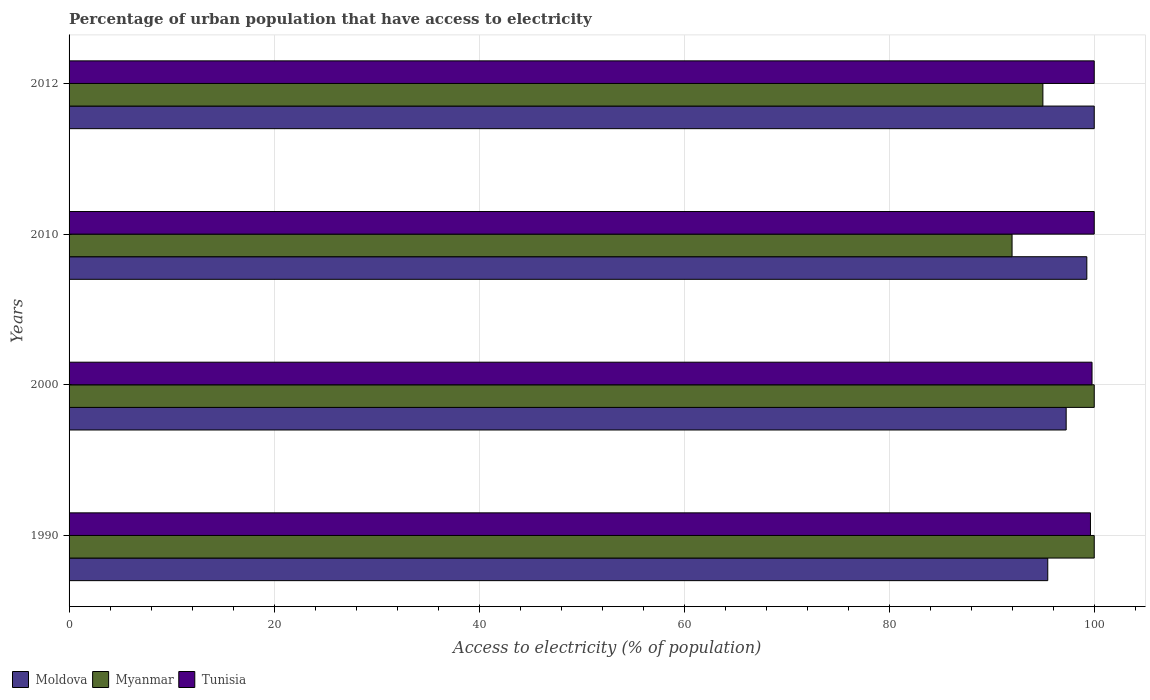How many groups of bars are there?
Provide a succinct answer. 4. How many bars are there on the 2nd tick from the bottom?
Give a very brief answer. 3. In how many cases, is the number of bars for a given year not equal to the number of legend labels?
Provide a short and direct response. 0. What is the percentage of urban population that have access to electricity in Moldova in 1990?
Your response must be concise. 95.47. Across all years, what is the minimum percentage of urban population that have access to electricity in Myanmar?
Provide a short and direct response. 91.99. In which year was the percentage of urban population that have access to electricity in Myanmar maximum?
Provide a short and direct response. 1990. What is the total percentage of urban population that have access to electricity in Tunisia in the graph?
Provide a succinct answer. 399.42. What is the difference between the percentage of urban population that have access to electricity in Moldova in 1990 and that in 2012?
Make the answer very short. -4.53. What is the difference between the percentage of urban population that have access to electricity in Tunisia in 2000 and the percentage of urban population that have access to electricity in Moldova in 2012?
Make the answer very short. -0.22. What is the average percentage of urban population that have access to electricity in Myanmar per year?
Your response must be concise. 96.74. In the year 2000, what is the difference between the percentage of urban population that have access to electricity in Tunisia and percentage of urban population that have access to electricity in Moldova?
Make the answer very short. 2.52. In how many years, is the percentage of urban population that have access to electricity in Myanmar greater than 84 %?
Offer a terse response. 4. What is the ratio of the percentage of urban population that have access to electricity in Myanmar in 2010 to that in 2012?
Your answer should be very brief. 0.97. Is the percentage of urban population that have access to electricity in Moldova in 1990 less than that in 2000?
Ensure brevity in your answer.  Yes. What is the difference between the highest and the lowest percentage of urban population that have access to electricity in Moldova?
Ensure brevity in your answer.  4.53. Is the sum of the percentage of urban population that have access to electricity in Tunisia in 1990 and 2012 greater than the maximum percentage of urban population that have access to electricity in Myanmar across all years?
Keep it short and to the point. Yes. What does the 2nd bar from the top in 1990 represents?
Provide a succinct answer. Myanmar. What does the 1st bar from the bottom in 2000 represents?
Offer a terse response. Moldova. Is it the case that in every year, the sum of the percentage of urban population that have access to electricity in Tunisia and percentage of urban population that have access to electricity in Moldova is greater than the percentage of urban population that have access to electricity in Myanmar?
Provide a short and direct response. Yes. Are all the bars in the graph horizontal?
Keep it short and to the point. Yes. Does the graph contain any zero values?
Offer a very short reply. No. Does the graph contain grids?
Give a very brief answer. Yes. Where does the legend appear in the graph?
Provide a succinct answer. Bottom left. How many legend labels are there?
Your answer should be very brief. 3. How are the legend labels stacked?
Ensure brevity in your answer.  Horizontal. What is the title of the graph?
Your answer should be very brief. Percentage of urban population that have access to electricity. Does "Central Europe" appear as one of the legend labels in the graph?
Provide a short and direct response. No. What is the label or title of the X-axis?
Your answer should be compact. Access to electricity (% of population). What is the label or title of the Y-axis?
Provide a succinct answer. Years. What is the Access to electricity (% of population) of Moldova in 1990?
Make the answer very short. 95.47. What is the Access to electricity (% of population) of Myanmar in 1990?
Your response must be concise. 100. What is the Access to electricity (% of population) of Tunisia in 1990?
Your response must be concise. 99.63. What is the Access to electricity (% of population) in Moldova in 2000?
Make the answer very short. 97.26. What is the Access to electricity (% of population) in Myanmar in 2000?
Make the answer very short. 100. What is the Access to electricity (% of population) of Tunisia in 2000?
Your response must be concise. 99.78. What is the Access to electricity (% of population) in Moldova in 2010?
Provide a short and direct response. 99.28. What is the Access to electricity (% of population) in Myanmar in 2010?
Your answer should be compact. 91.99. What is the Access to electricity (% of population) in Tunisia in 2010?
Ensure brevity in your answer.  100. What is the Access to electricity (% of population) in Myanmar in 2012?
Make the answer very short. 94.99. What is the Access to electricity (% of population) in Tunisia in 2012?
Provide a succinct answer. 100. Across all years, what is the maximum Access to electricity (% of population) in Tunisia?
Keep it short and to the point. 100. Across all years, what is the minimum Access to electricity (% of population) in Moldova?
Keep it short and to the point. 95.47. Across all years, what is the minimum Access to electricity (% of population) in Myanmar?
Give a very brief answer. 91.99. Across all years, what is the minimum Access to electricity (% of population) in Tunisia?
Ensure brevity in your answer.  99.63. What is the total Access to electricity (% of population) of Moldova in the graph?
Your answer should be compact. 392.01. What is the total Access to electricity (% of population) of Myanmar in the graph?
Make the answer very short. 386.98. What is the total Access to electricity (% of population) of Tunisia in the graph?
Your answer should be very brief. 399.42. What is the difference between the Access to electricity (% of population) of Moldova in 1990 and that in 2000?
Ensure brevity in your answer.  -1.8. What is the difference between the Access to electricity (% of population) of Myanmar in 1990 and that in 2000?
Ensure brevity in your answer.  0. What is the difference between the Access to electricity (% of population) of Tunisia in 1990 and that in 2000?
Offer a terse response. -0.15. What is the difference between the Access to electricity (% of population) in Moldova in 1990 and that in 2010?
Your response must be concise. -3.81. What is the difference between the Access to electricity (% of population) of Myanmar in 1990 and that in 2010?
Provide a succinct answer. 8.01. What is the difference between the Access to electricity (% of population) in Tunisia in 1990 and that in 2010?
Your answer should be compact. -0.37. What is the difference between the Access to electricity (% of population) of Moldova in 1990 and that in 2012?
Your response must be concise. -4.53. What is the difference between the Access to electricity (% of population) of Myanmar in 1990 and that in 2012?
Offer a terse response. 5.01. What is the difference between the Access to electricity (% of population) of Tunisia in 1990 and that in 2012?
Offer a very short reply. -0.37. What is the difference between the Access to electricity (% of population) in Moldova in 2000 and that in 2010?
Your answer should be very brief. -2.02. What is the difference between the Access to electricity (% of population) of Myanmar in 2000 and that in 2010?
Give a very brief answer. 8.01. What is the difference between the Access to electricity (% of population) in Tunisia in 2000 and that in 2010?
Give a very brief answer. -0.22. What is the difference between the Access to electricity (% of population) in Moldova in 2000 and that in 2012?
Offer a terse response. -2.74. What is the difference between the Access to electricity (% of population) in Myanmar in 2000 and that in 2012?
Your answer should be very brief. 5.01. What is the difference between the Access to electricity (% of population) in Tunisia in 2000 and that in 2012?
Your answer should be very brief. -0.22. What is the difference between the Access to electricity (% of population) of Moldova in 2010 and that in 2012?
Make the answer very short. -0.72. What is the difference between the Access to electricity (% of population) in Myanmar in 2010 and that in 2012?
Keep it short and to the point. -3.01. What is the difference between the Access to electricity (% of population) of Moldova in 1990 and the Access to electricity (% of population) of Myanmar in 2000?
Offer a terse response. -4.53. What is the difference between the Access to electricity (% of population) of Moldova in 1990 and the Access to electricity (% of population) of Tunisia in 2000?
Offer a very short reply. -4.32. What is the difference between the Access to electricity (% of population) in Myanmar in 1990 and the Access to electricity (% of population) in Tunisia in 2000?
Provide a short and direct response. 0.22. What is the difference between the Access to electricity (% of population) in Moldova in 1990 and the Access to electricity (% of population) in Myanmar in 2010?
Your response must be concise. 3.48. What is the difference between the Access to electricity (% of population) of Moldova in 1990 and the Access to electricity (% of population) of Tunisia in 2010?
Your answer should be very brief. -4.53. What is the difference between the Access to electricity (% of population) of Moldova in 1990 and the Access to electricity (% of population) of Myanmar in 2012?
Your response must be concise. 0.47. What is the difference between the Access to electricity (% of population) of Moldova in 1990 and the Access to electricity (% of population) of Tunisia in 2012?
Provide a short and direct response. -4.53. What is the difference between the Access to electricity (% of population) in Moldova in 2000 and the Access to electricity (% of population) in Myanmar in 2010?
Your answer should be very brief. 5.28. What is the difference between the Access to electricity (% of population) in Moldova in 2000 and the Access to electricity (% of population) in Tunisia in 2010?
Offer a terse response. -2.74. What is the difference between the Access to electricity (% of population) in Moldova in 2000 and the Access to electricity (% of population) in Myanmar in 2012?
Ensure brevity in your answer.  2.27. What is the difference between the Access to electricity (% of population) of Moldova in 2000 and the Access to electricity (% of population) of Tunisia in 2012?
Provide a succinct answer. -2.74. What is the difference between the Access to electricity (% of population) in Moldova in 2010 and the Access to electricity (% of population) in Myanmar in 2012?
Ensure brevity in your answer.  4.29. What is the difference between the Access to electricity (% of population) in Moldova in 2010 and the Access to electricity (% of population) in Tunisia in 2012?
Offer a very short reply. -0.72. What is the difference between the Access to electricity (% of population) of Myanmar in 2010 and the Access to electricity (% of population) of Tunisia in 2012?
Make the answer very short. -8.01. What is the average Access to electricity (% of population) of Moldova per year?
Ensure brevity in your answer.  98. What is the average Access to electricity (% of population) of Myanmar per year?
Provide a succinct answer. 96.74. What is the average Access to electricity (% of population) in Tunisia per year?
Your response must be concise. 99.85. In the year 1990, what is the difference between the Access to electricity (% of population) in Moldova and Access to electricity (% of population) in Myanmar?
Your answer should be very brief. -4.53. In the year 1990, what is the difference between the Access to electricity (% of population) in Moldova and Access to electricity (% of population) in Tunisia?
Ensure brevity in your answer.  -4.17. In the year 1990, what is the difference between the Access to electricity (% of population) of Myanmar and Access to electricity (% of population) of Tunisia?
Give a very brief answer. 0.37. In the year 2000, what is the difference between the Access to electricity (% of population) of Moldova and Access to electricity (% of population) of Myanmar?
Provide a short and direct response. -2.74. In the year 2000, what is the difference between the Access to electricity (% of population) of Moldova and Access to electricity (% of population) of Tunisia?
Your response must be concise. -2.52. In the year 2000, what is the difference between the Access to electricity (% of population) in Myanmar and Access to electricity (% of population) in Tunisia?
Make the answer very short. 0.22. In the year 2010, what is the difference between the Access to electricity (% of population) in Moldova and Access to electricity (% of population) in Myanmar?
Your answer should be very brief. 7.29. In the year 2010, what is the difference between the Access to electricity (% of population) in Moldova and Access to electricity (% of population) in Tunisia?
Provide a succinct answer. -0.72. In the year 2010, what is the difference between the Access to electricity (% of population) in Myanmar and Access to electricity (% of population) in Tunisia?
Provide a short and direct response. -8.01. In the year 2012, what is the difference between the Access to electricity (% of population) in Moldova and Access to electricity (% of population) in Myanmar?
Ensure brevity in your answer.  5.01. In the year 2012, what is the difference between the Access to electricity (% of population) of Moldova and Access to electricity (% of population) of Tunisia?
Provide a short and direct response. 0. In the year 2012, what is the difference between the Access to electricity (% of population) in Myanmar and Access to electricity (% of population) in Tunisia?
Ensure brevity in your answer.  -5.01. What is the ratio of the Access to electricity (% of population) of Moldova in 1990 to that in 2000?
Make the answer very short. 0.98. What is the ratio of the Access to electricity (% of population) of Myanmar in 1990 to that in 2000?
Provide a succinct answer. 1. What is the ratio of the Access to electricity (% of population) of Moldova in 1990 to that in 2010?
Make the answer very short. 0.96. What is the ratio of the Access to electricity (% of population) in Myanmar in 1990 to that in 2010?
Keep it short and to the point. 1.09. What is the ratio of the Access to electricity (% of population) in Moldova in 1990 to that in 2012?
Your response must be concise. 0.95. What is the ratio of the Access to electricity (% of population) of Myanmar in 1990 to that in 2012?
Keep it short and to the point. 1.05. What is the ratio of the Access to electricity (% of population) of Moldova in 2000 to that in 2010?
Your response must be concise. 0.98. What is the ratio of the Access to electricity (% of population) in Myanmar in 2000 to that in 2010?
Your response must be concise. 1.09. What is the ratio of the Access to electricity (% of population) of Moldova in 2000 to that in 2012?
Provide a succinct answer. 0.97. What is the ratio of the Access to electricity (% of population) in Myanmar in 2000 to that in 2012?
Provide a succinct answer. 1.05. What is the ratio of the Access to electricity (% of population) of Tunisia in 2000 to that in 2012?
Your answer should be very brief. 1. What is the ratio of the Access to electricity (% of population) in Moldova in 2010 to that in 2012?
Your answer should be very brief. 0.99. What is the ratio of the Access to electricity (% of population) of Myanmar in 2010 to that in 2012?
Your response must be concise. 0.97. What is the difference between the highest and the second highest Access to electricity (% of population) in Moldova?
Your answer should be compact. 0.72. What is the difference between the highest and the second highest Access to electricity (% of population) in Myanmar?
Keep it short and to the point. 0. What is the difference between the highest and the lowest Access to electricity (% of population) of Moldova?
Your answer should be compact. 4.53. What is the difference between the highest and the lowest Access to electricity (% of population) in Myanmar?
Provide a succinct answer. 8.01. What is the difference between the highest and the lowest Access to electricity (% of population) in Tunisia?
Ensure brevity in your answer.  0.37. 